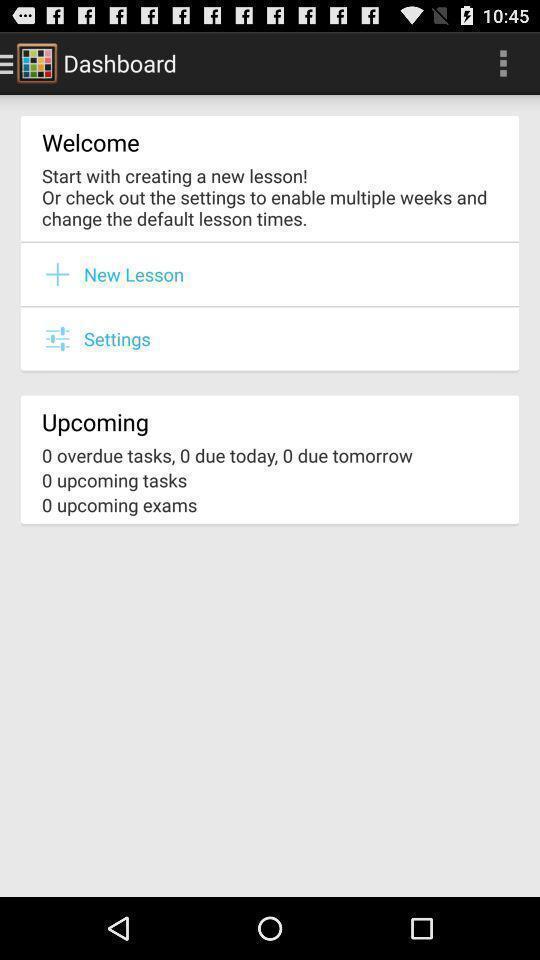Describe the key features of this screenshot. Welcome page. 